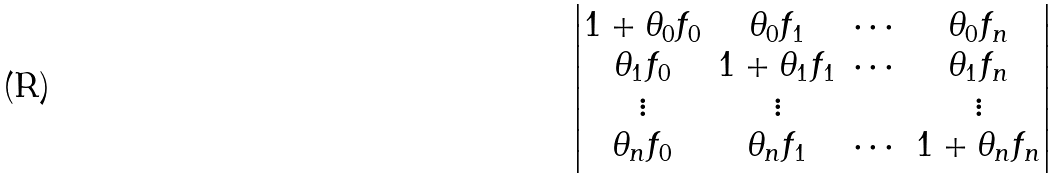Convert formula to latex. <formula><loc_0><loc_0><loc_500><loc_500>\begin{vmatrix} 1 + \theta _ { 0 } f _ { 0 } & \theta _ { 0 } f _ { 1 } & \cdots & \theta _ { 0 } f _ { n } \\ \theta _ { 1 } f _ { 0 } & 1 + \theta _ { 1 } f _ { 1 } & \cdots & \theta _ { 1 } f _ { n } \\ \vdots & \vdots & & \vdots \\ \theta _ { n } f _ { 0 } & \theta _ { n } f _ { 1 } & \cdots & 1 + \theta _ { n } f _ { n } \end{vmatrix}</formula> 